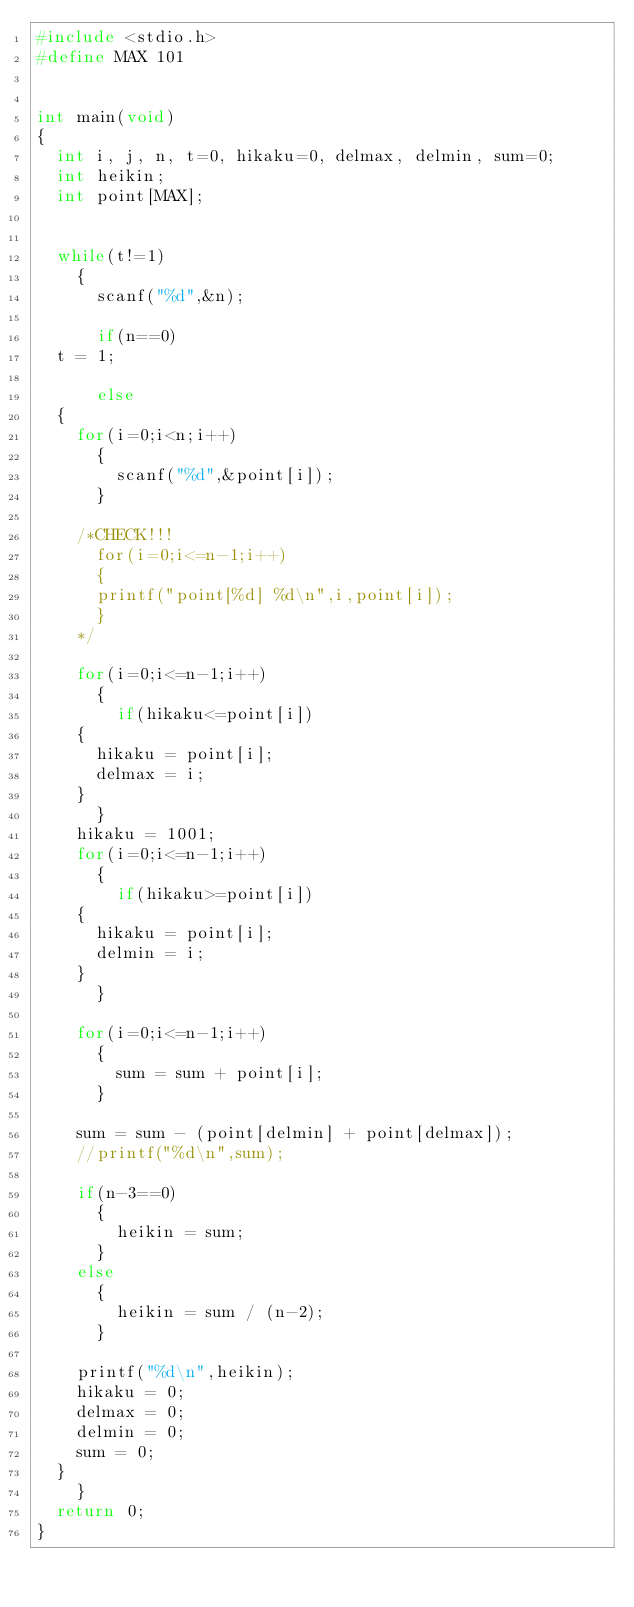<code> <loc_0><loc_0><loc_500><loc_500><_C_>#include <stdio.h>
#define MAX 101


int main(void)
{
  int i, j, n, t=0, hikaku=0, delmax, delmin, sum=0;
  int heikin;
  int point[MAX];


  while(t!=1)
    {
      scanf("%d",&n);
      
      if(n==0)
	t = 1;

      else
	{
	  for(i=0;i<n;i++)
	    {
	      scanf("%d",&point[i]);
	    }
	  
	  /*CHECK!!!
	    for(i=0;i<=n-1;i++)
	    {
	    printf("point[%d] %d\n",i,point[i]);
	    }
	  */
	  
	  for(i=0;i<=n-1;i++)
	    {
	      if(hikaku<=point[i])
		{
		  hikaku = point[i];
		  delmax = i;
		}
	    }
	  hikaku = 1001;
	  for(i=0;i<=n-1;i++)
	    {
	      if(hikaku>=point[i])
		{
		  hikaku = point[i];
		  delmin = i;
		}
	    }
	  
	  for(i=0;i<=n-1;i++)
	    {
	      sum = sum + point[i];
	    }
	  
	  sum = sum - (point[delmin] + point[delmax]);
	  //printf("%d\n",sum);

	  if(n-3==0)
	    {
	      heikin = sum;
	    }
	  else
	    {
	      heikin = sum / (n-2);
	    }

	  printf("%d\n",heikin);
	  hikaku = 0;
	  delmax = 0;
	  delmin = 0;
	  sum = 0;
	}
    }
  return 0;
}</code> 